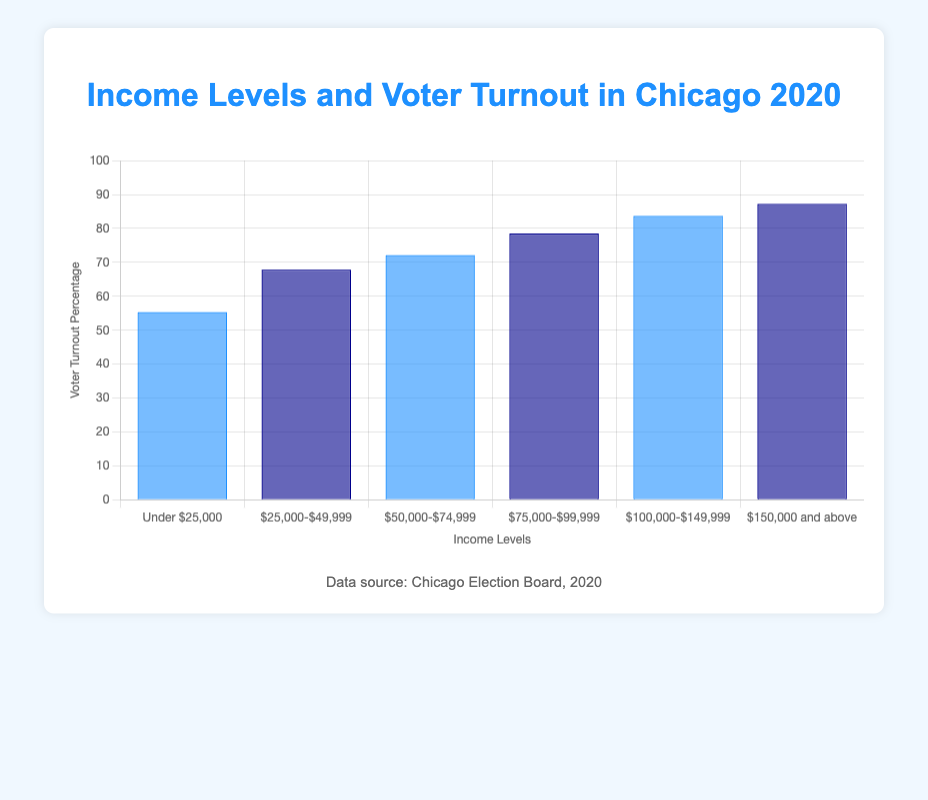What's the voter turnout percentage for income levels $50,000-$74,999? Refer to the income level "$50,000-$74,999" from the bar chart. The corresponding height of the bar indicates the voter turnout percentage.
Answer: 72.1% For which income range is the voter turnout highest? Look at all the bars in the chart and identify the bar with the maximum height. The label of this bar corresponds to the income range with the highest voter turnout.
Answer: $150,000 and above Which two adjacent income ranges have the largest increase in voter turnout percentage? Compare the voter turnout percentages between adjacent income ranges. Calculate the difference for each pair and identify the pair with the largest difference.
Answer: $100,000-$149,999 and $150,000 and above How much higher is the voter turnout for those earning over $150,000 compared to those earning under $25,000? Lookup the voter turnout percentages for the income ranges "Under $25,000" and "$150,000 and above". Subtract the smaller percentage from the larger percentage to find the difference. 87.2% - 55.3% = 31.9%
Answer: 31.9% What's the average voter turnout percentage across all income levels? Add the voter turnout percentages for all income levels and divide by the number of income levels. (55.3 + 67.8 + 72.1 + 78.5 + 83.7 + 87.2)/6 ≈ 74.1%
Answer: 74.1% For which income range is the voter turnout percentage closest to the overall average? First, calculate the average voter turnout percentage (as done in the previous question: 74.1%). Then, find the income range whose voter turnout percentage has the smallest difference from this average. The income range "$75,000-$99,999" is closest with 78.5%.
Answer: $75,000-$99,999 